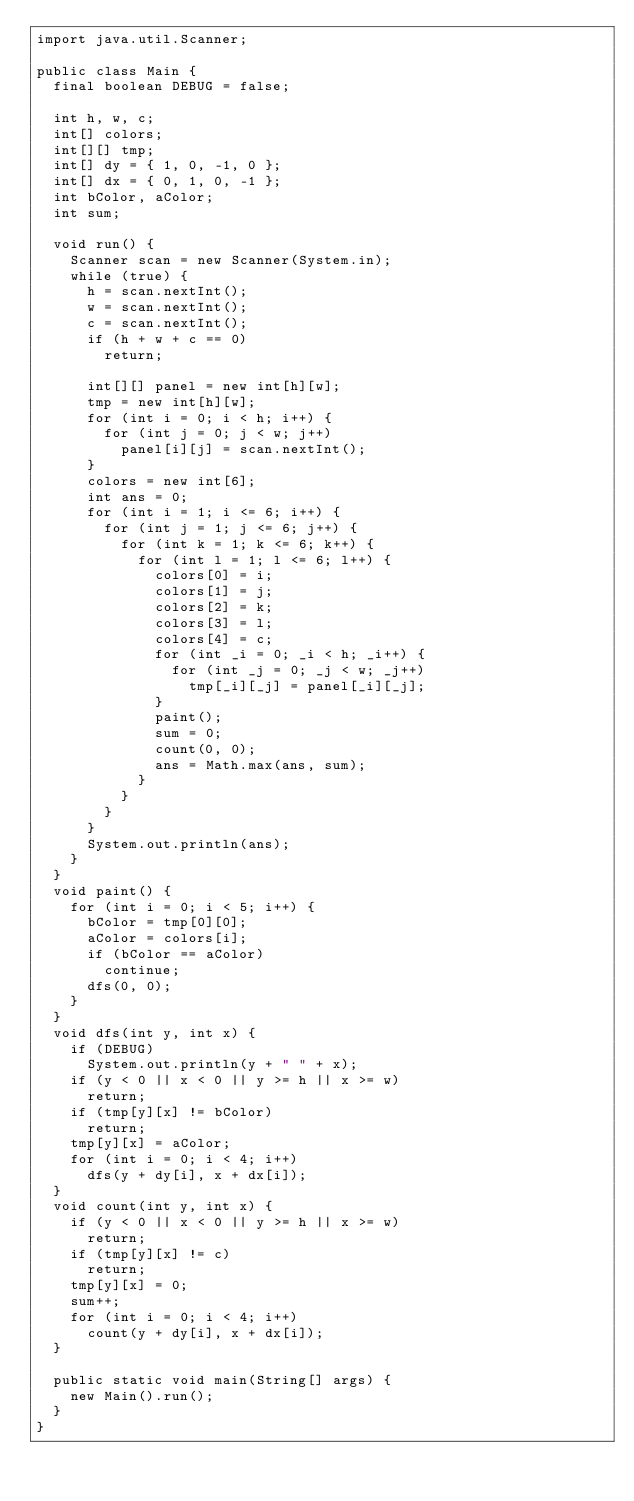<code> <loc_0><loc_0><loc_500><loc_500><_Java_>import java.util.Scanner;

public class Main {
	final boolean DEBUG = false;

	int h, w, c;
	int[] colors;
	int[][] tmp;
	int[] dy = { 1, 0, -1, 0 };
	int[] dx = { 0, 1, 0, -1 };
	int bColor, aColor;
	int sum;

	void run() {
		Scanner scan = new Scanner(System.in);
		while (true) {
			h = scan.nextInt();
			w = scan.nextInt();
			c = scan.nextInt();
			if (h + w + c == 0)
				return;

			int[][] panel = new int[h][w];
			tmp = new int[h][w];
			for (int i = 0; i < h; i++) {
				for (int j = 0; j < w; j++)
					panel[i][j] = scan.nextInt();
			}
			colors = new int[6];
			int ans = 0;
			for (int i = 1; i <= 6; i++) {
				for (int j = 1; j <= 6; j++) {
					for (int k = 1; k <= 6; k++) {
						for (int l = 1; l <= 6; l++) {
							colors[0] = i;
							colors[1] = j;
							colors[2] = k;
							colors[3] = l;
							colors[4] = c;
							for (int _i = 0; _i < h; _i++) {
								for (int _j = 0; _j < w; _j++)
									tmp[_i][_j] = panel[_i][_j];
							}
							paint();
							sum = 0;
							count(0, 0);
							ans = Math.max(ans, sum);
						}
					}
				}
			}
			System.out.println(ans);
		}
	}
	void paint() {
		for (int i = 0; i < 5; i++) {
			bColor = tmp[0][0];
			aColor = colors[i];
			if (bColor == aColor)
				continue;
			dfs(0, 0);
		}
	}
	void dfs(int y, int x) {
		if (DEBUG)
			System.out.println(y + " " + x);
		if (y < 0 || x < 0 || y >= h || x >= w)
			return;
		if (tmp[y][x] != bColor)
			return;
		tmp[y][x] = aColor;
		for (int i = 0; i < 4; i++)
			dfs(y + dy[i], x + dx[i]);
	}
	void count(int y, int x) {
		if (y < 0 || x < 0 || y >= h || x >= w)
			return;
		if (tmp[y][x] != c)
			return;
		tmp[y][x] = 0;
		sum++;
		for (int i = 0; i < 4; i++)
			count(y + dy[i], x + dx[i]);
	}
	
	public static void main(String[] args) {
		new Main().run();
	}
}

</code> 